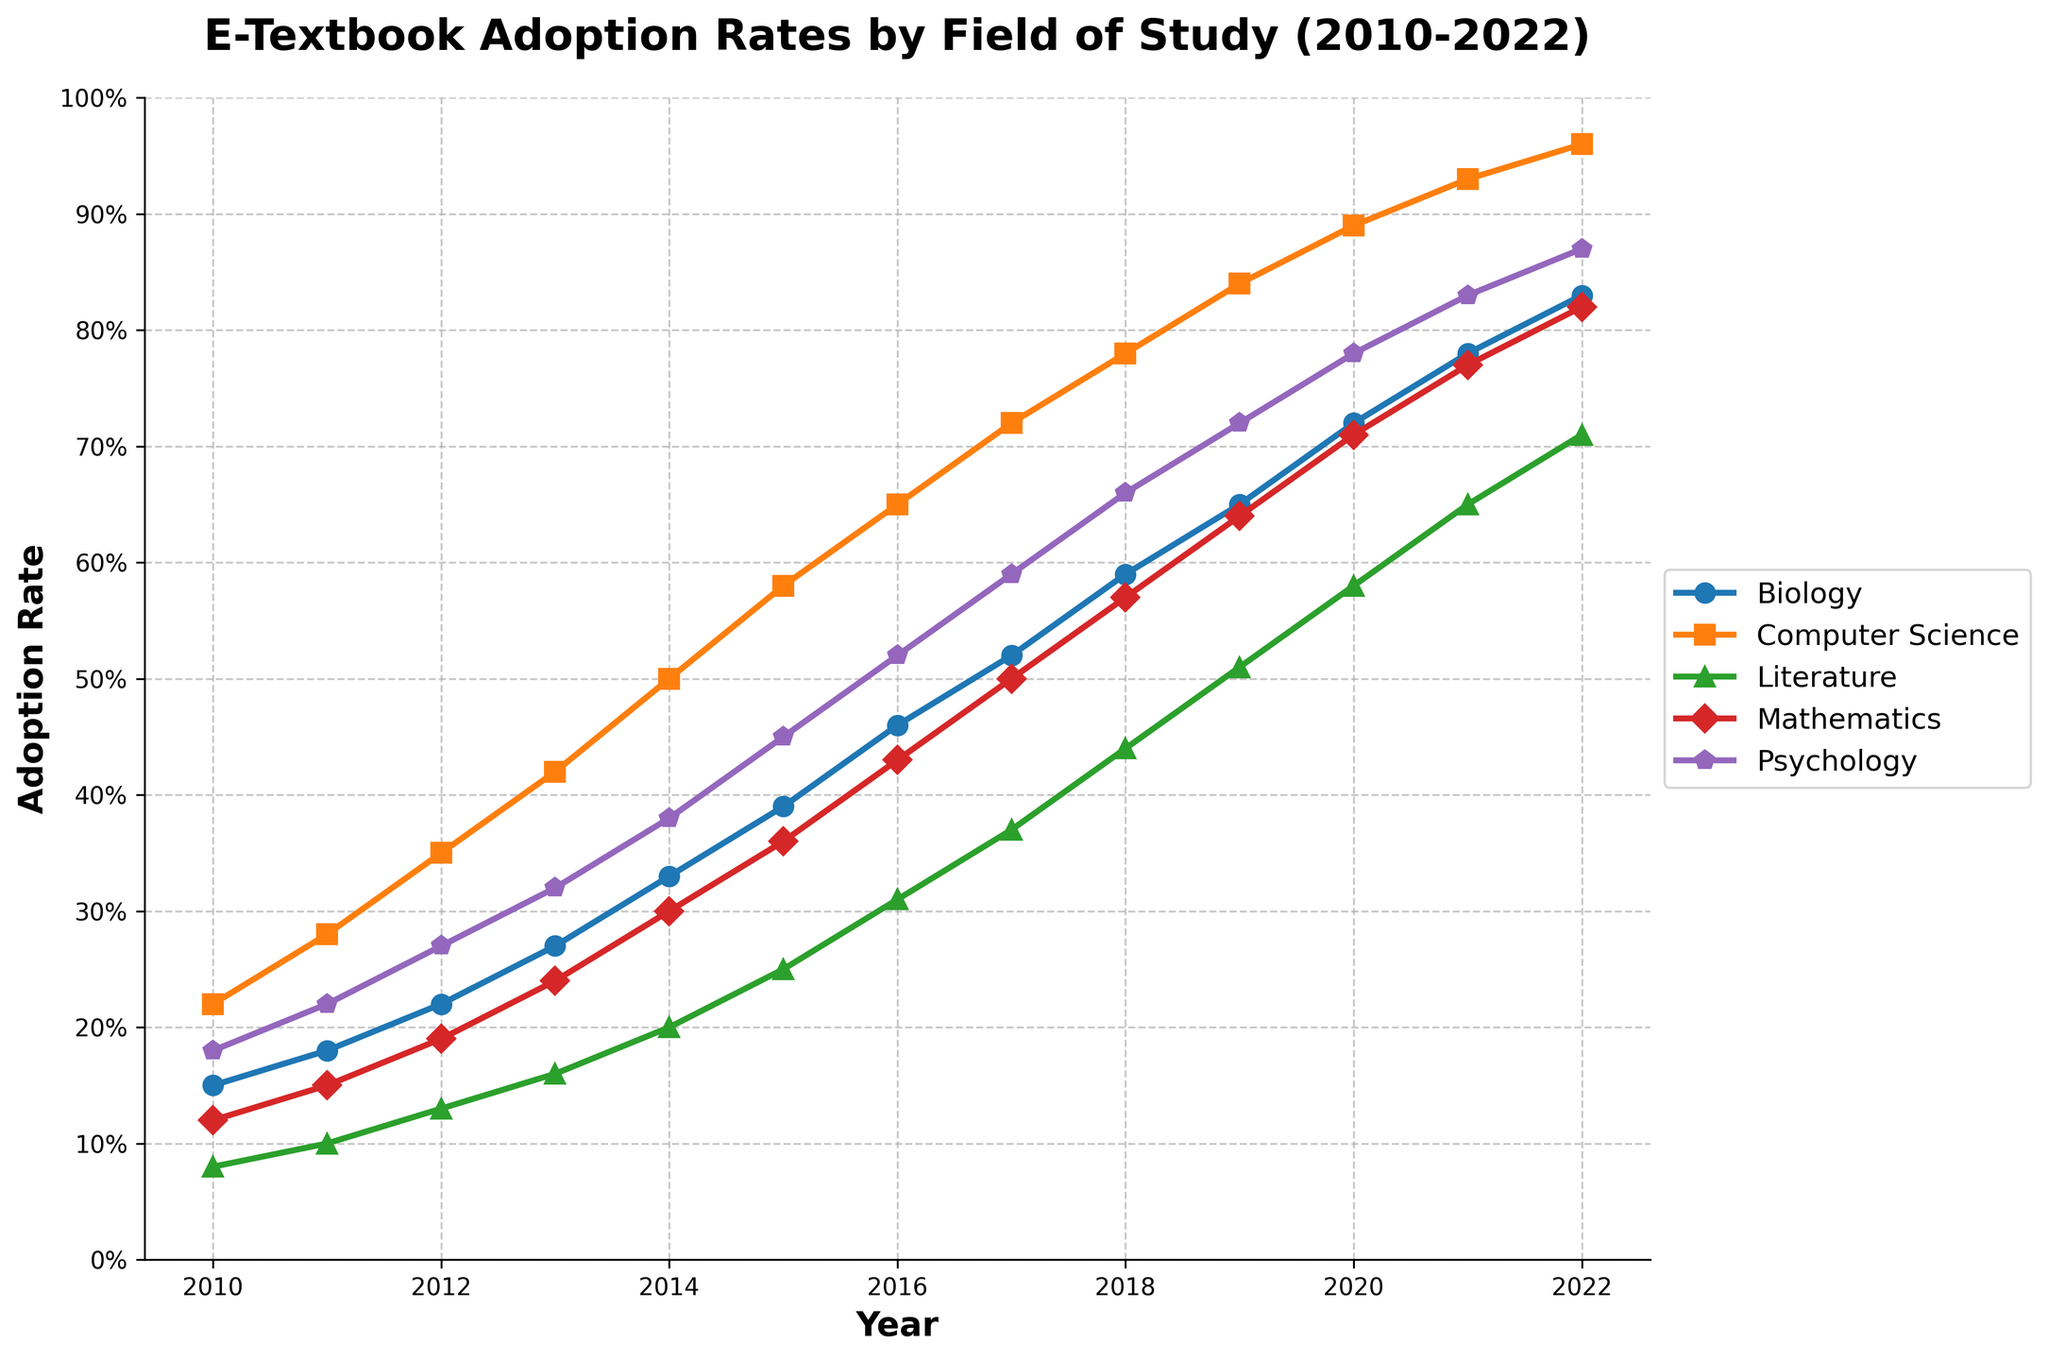What was the adoption rate for e-textbooks in Literature in 2015? Referring to the figure, look at the adoption rate line for Literature in 2015. The point on the line shows the adoption rate.
Answer: 25% Which field had the highest e-textbook adoption rate in 2020, and what was the percentage? Identify the highest point among all the fields in the year 2020 from the graph. In this case, the highest point belongs to Computer Science.
Answer: Computer Science, 89% How does the adoption rate for Mathematics in 2016 compare to the adoption rate for Psychology in the same year? Locate the points for both Mathematics and Psychology in the year 2016 from the figure and compare their heights. The Mathematics adoption rate was 43%, and the Psychology adoption rate was 52%.
Answer: Psychology was higher by 9% What is the average e-textbook adoption rate of Biology from 2018 to 2020? First, find the adoption rates for Biology in the years 2018, 2019, and 2020 from the graph. Then, sum these rates and divide by the number of years (3). The rates are 59%, 65%, and 72%. (59 + 65 + 72) / 3
Answer: 65.33% By how much did the adoption rate for Computer Science increase from 2010 to 2022? Look for the adoption rates of Computer Science in 2010 and 2022 on the figure. Subtract the earlier rate from the later rate. The rates are 22% and 96%, respectively. 96% - 22% = 74%
Answer: 74% Which two fields of study had the closest adoption rates in 2013, and what were those rates? Examine the adoption rates for all fields in 2013 and identify any two with minimal difference. Biology and Psychology had adoption rates of 27% and 32%, respectively.
Answer: Biology and Psychology, 27% and 32% What is the trend in e-textbook adoption rate for Mathematics from 2010 to 2022? Observe the adoption rate line for Mathematics over the years. Describe whether it is increasing, decreasing, or stable. The rate shows a generally increasing trend.
Answer: Increasing Between 2014 and 2015, which field saw the greatest increase in e-textbook adoption rate? Calculate the differences in adoption rates between 2014 and 2015 for each field by checking the figure. The largest difference is seen in Biology, with an increase from 33% to 39%, which is 6%.
Answer: Biology Combine the adoption rates of Literature and Computer Science in 2021. What total percentage does this give? Locate the adoption rates for Literature and Computer Science in 2021 from the graph. Sum these rates to get the total percentage. The rates are 65% and 93%, respectively. 65% + 93% = 158%
Answer: 158% 